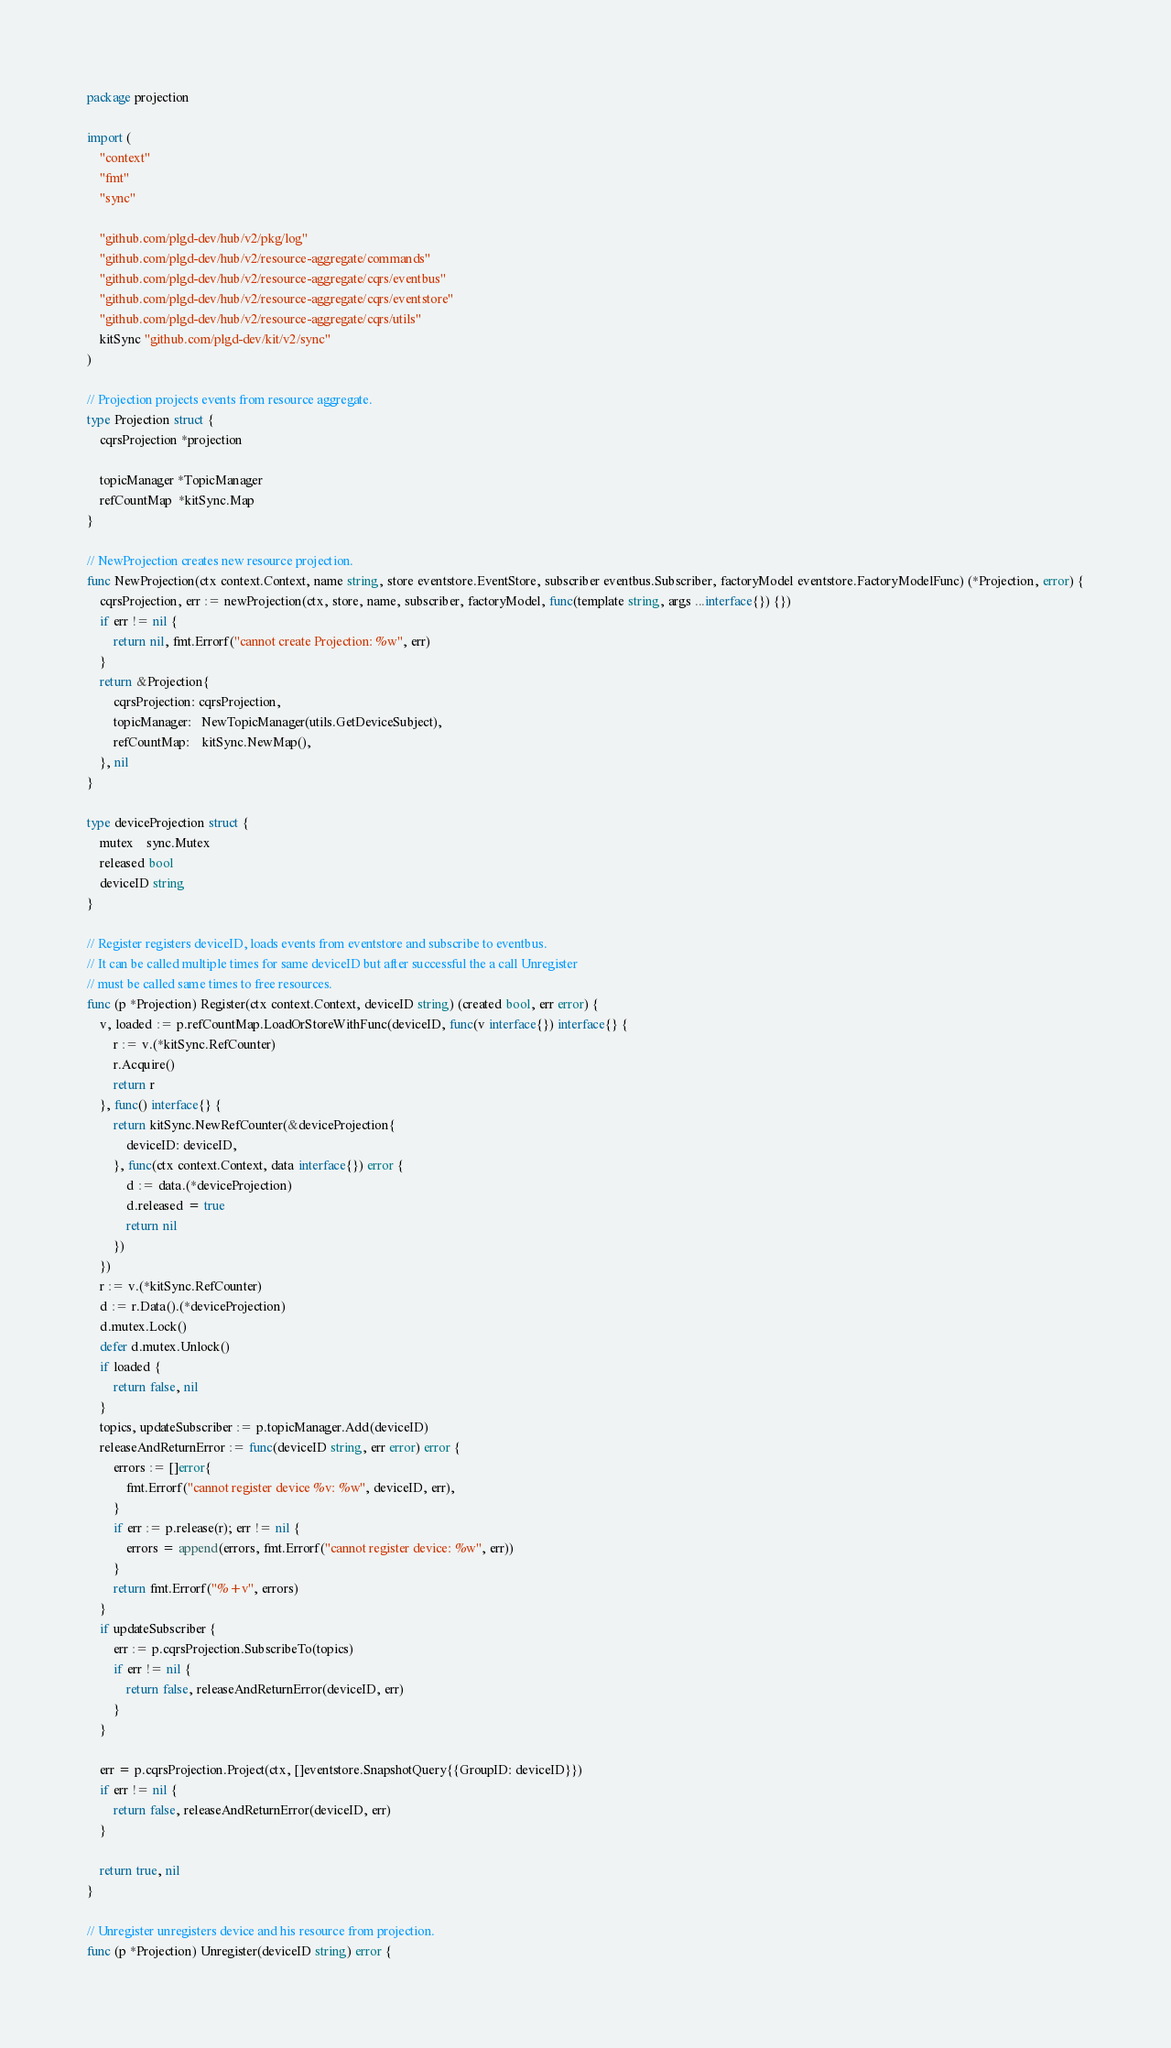<code> <loc_0><loc_0><loc_500><loc_500><_Go_>package projection

import (
	"context"
	"fmt"
	"sync"

	"github.com/plgd-dev/hub/v2/pkg/log"
	"github.com/plgd-dev/hub/v2/resource-aggregate/commands"
	"github.com/plgd-dev/hub/v2/resource-aggregate/cqrs/eventbus"
	"github.com/plgd-dev/hub/v2/resource-aggregate/cqrs/eventstore"
	"github.com/plgd-dev/hub/v2/resource-aggregate/cqrs/utils"
	kitSync "github.com/plgd-dev/kit/v2/sync"
)

// Projection projects events from resource aggregate.
type Projection struct {
	cqrsProjection *projection

	topicManager *TopicManager
	refCountMap  *kitSync.Map
}

// NewProjection creates new resource projection.
func NewProjection(ctx context.Context, name string, store eventstore.EventStore, subscriber eventbus.Subscriber, factoryModel eventstore.FactoryModelFunc) (*Projection, error) {
	cqrsProjection, err := newProjection(ctx, store, name, subscriber, factoryModel, func(template string, args ...interface{}) {})
	if err != nil {
		return nil, fmt.Errorf("cannot create Projection: %w", err)
	}
	return &Projection{
		cqrsProjection: cqrsProjection,
		topicManager:   NewTopicManager(utils.GetDeviceSubject),
		refCountMap:    kitSync.NewMap(),
	}, nil
}

type deviceProjection struct {
	mutex    sync.Mutex
	released bool
	deviceID string
}

// Register registers deviceID, loads events from eventstore and subscribe to eventbus.
// It can be called multiple times for same deviceID but after successful the a call Unregister
// must be called same times to free resources.
func (p *Projection) Register(ctx context.Context, deviceID string) (created bool, err error) {
	v, loaded := p.refCountMap.LoadOrStoreWithFunc(deviceID, func(v interface{}) interface{} {
		r := v.(*kitSync.RefCounter)
		r.Acquire()
		return r
	}, func() interface{} {
		return kitSync.NewRefCounter(&deviceProjection{
			deviceID: deviceID,
		}, func(ctx context.Context, data interface{}) error {
			d := data.(*deviceProjection)
			d.released = true
			return nil
		})
	})
	r := v.(*kitSync.RefCounter)
	d := r.Data().(*deviceProjection)
	d.mutex.Lock()
	defer d.mutex.Unlock()
	if loaded {
		return false, nil
	}
	topics, updateSubscriber := p.topicManager.Add(deviceID)
	releaseAndReturnError := func(deviceID string, err error) error {
		errors := []error{
			fmt.Errorf("cannot register device %v: %w", deviceID, err),
		}
		if err := p.release(r); err != nil {
			errors = append(errors, fmt.Errorf("cannot register device: %w", err))
		}
		return fmt.Errorf("%+v", errors)
	}
	if updateSubscriber {
		err := p.cqrsProjection.SubscribeTo(topics)
		if err != nil {
			return false, releaseAndReturnError(deviceID, err)
		}
	}

	err = p.cqrsProjection.Project(ctx, []eventstore.SnapshotQuery{{GroupID: deviceID}})
	if err != nil {
		return false, releaseAndReturnError(deviceID, err)
	}

	return true, nil
}

// Unregister unregisters device and his resource from projection.
func (p *Projection) Unregister(deviceID string) error {</code> 